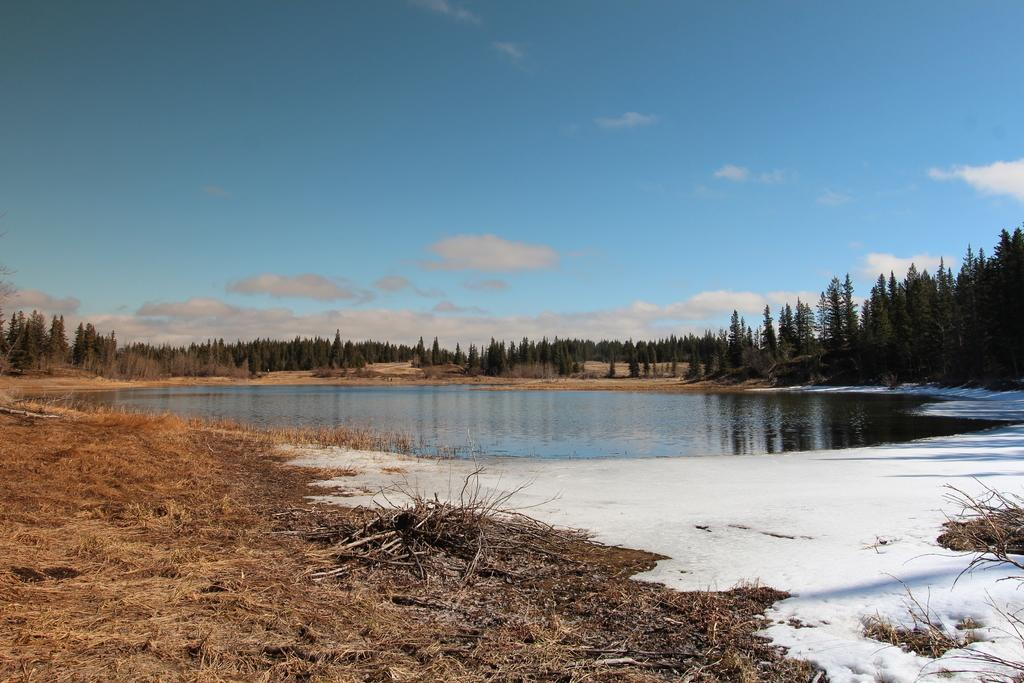What type of body of water is present in the image? There is a lake in the image. What can be seen in the background of the image? There are trees in the background of the image. Where are the trees located? The trees are on a grassland. What is visible at the top of the image? The sky is visible at the top of the image. What is the condition of the sky in the image? The sky has clouds in the image. How many men are involved in the crime depicted in the image? There is no crime or men present in the image. The image features a lake, trees, grassland, and a cloudy sky. 